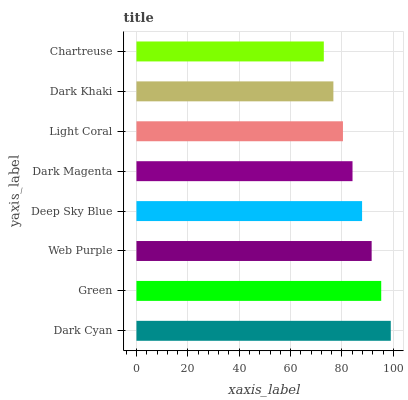Is Chartreuse the minimum?
Answer yes or no. Yes. Is Dark Cyan the maximum?
Answer yes or no. Yes. Is Green the minimum?
Answer yes or no. No. Is Green the maximum?
Answer yes or no. No. Is Dark Cyan greater than Green?
Answer yes or no. Yes. Is Green less than Dark Cyan?
Answer yes or no. Yes. Is Green greater than Dark Cyan?
Answer yes or no. No. Is Dark Cyan less than Green?
Answer yes or no. No. Is Deep Sky Blue the high median?
Answer yes or no. Yes. Is Dark Magenta the low median?
Answer yes or no. Yes. Is Light Coral the high median?
Answer yes or no. No. Is Light Coral the low median?
Answer yes or no. No. 